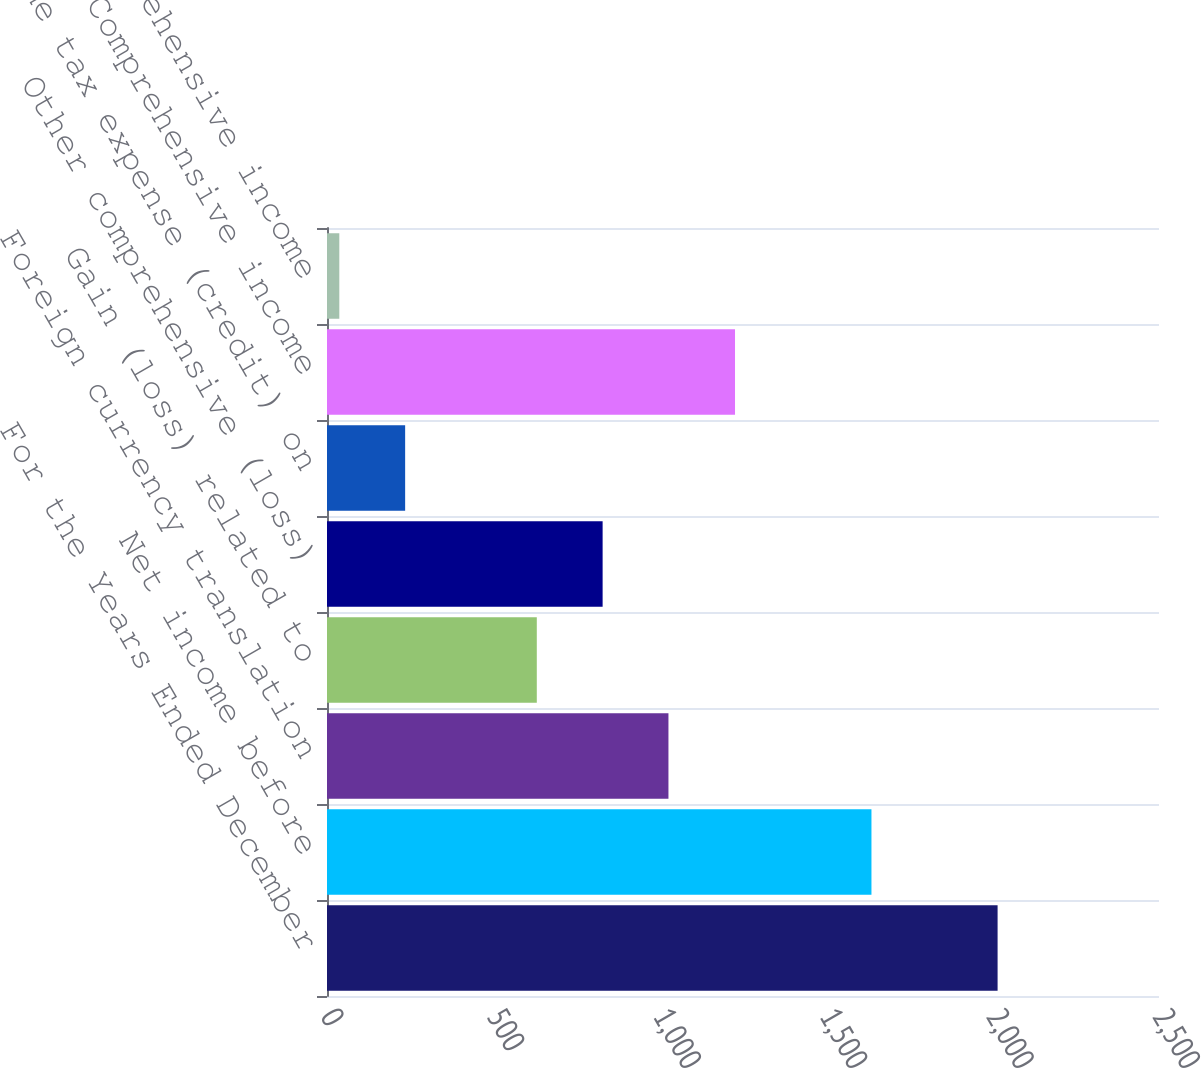Convert chart. <chart><loc_0><loc_0><loc_500><loc_500><bar_chart><fcel>For the Years Ended December<fcel>Net income before<fcel>Foreign currency translation<fcel>Gain (loss) related to<fcel>Other comprehensive (loss)<fcel>Income tax expense (credit) on<fcel>Comprehensive income<fcel>Less Comprehensive income<nl><fcel>2015<fcel>1636<fcel>1026<fcel>630.4<fcel>828.2<fcel>234.8<fcel>1226<fcel>37<nl></chart> 